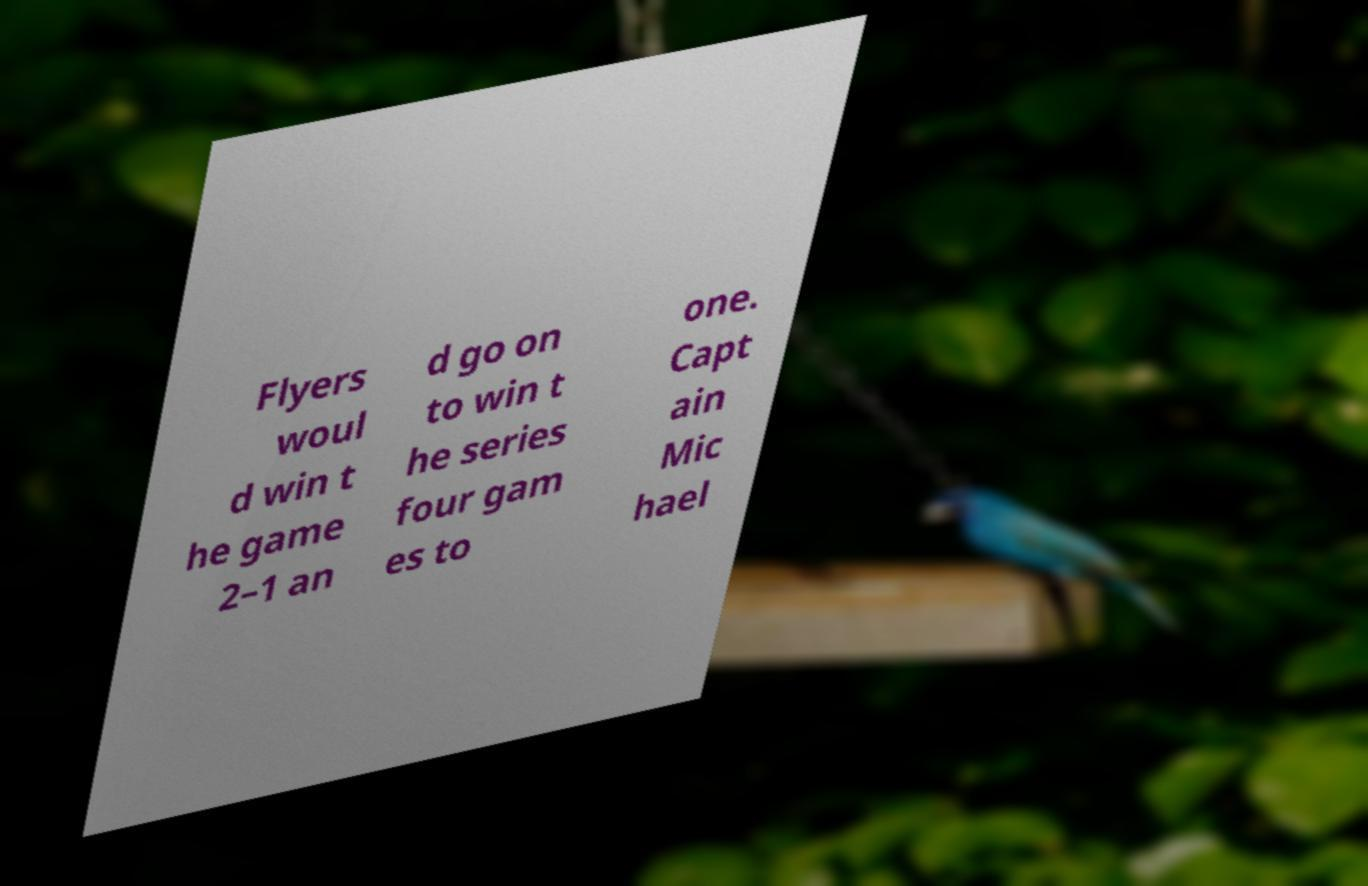For documentation purposes, I need the text within this image transcribed. Could you provide that? Flyers woul d win t he game 2–1 an d go on to win t he series four gam es to one. Capt ain Mic hael 